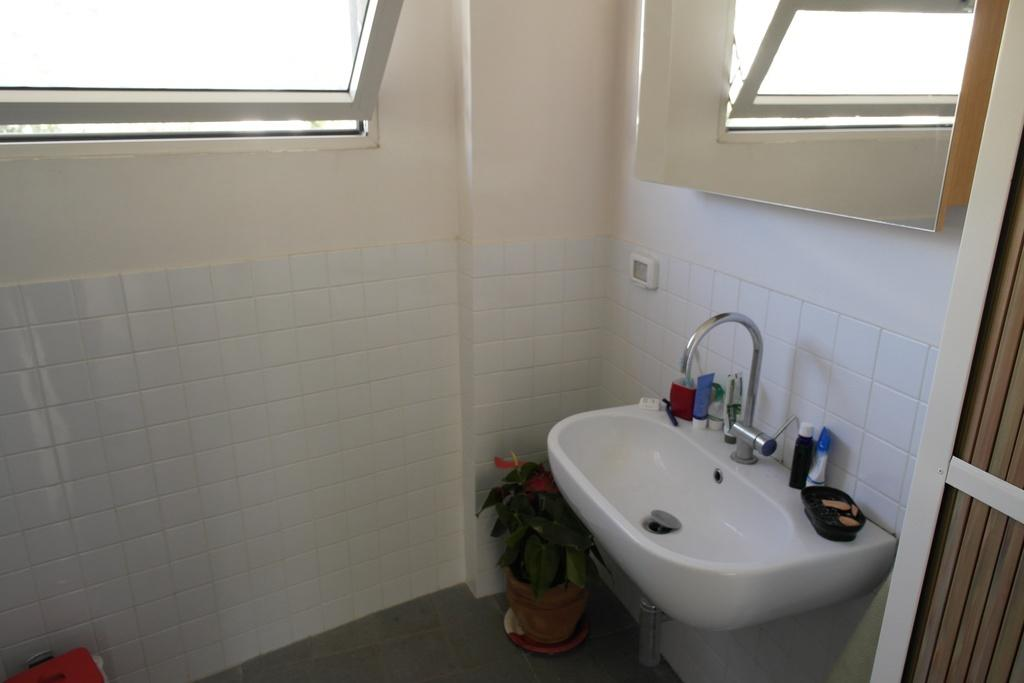What type of plant can be seen in the image? There is a potted plant in the image. What is the primary feature of the sink in the image? There is a tap in the image, which is a part of the sink. What can be found near the sink in the image? There are bottles and a soap container in the image. What is the background of the image made of? There is a wall in the image, which serves as the background. What is used for reflection in the image? There is a mirror in the image. What allows natural light to enter the room in the image? There is a window in the image. Can you describe the possible exit in the image? There might be a door on the right side of the image. What type of toys can be seen in the image? There are no toys present in the image. What sense is being stimulated by the potted plant in the image? The image does not depict any sensory stimulation related to the potted plant. 